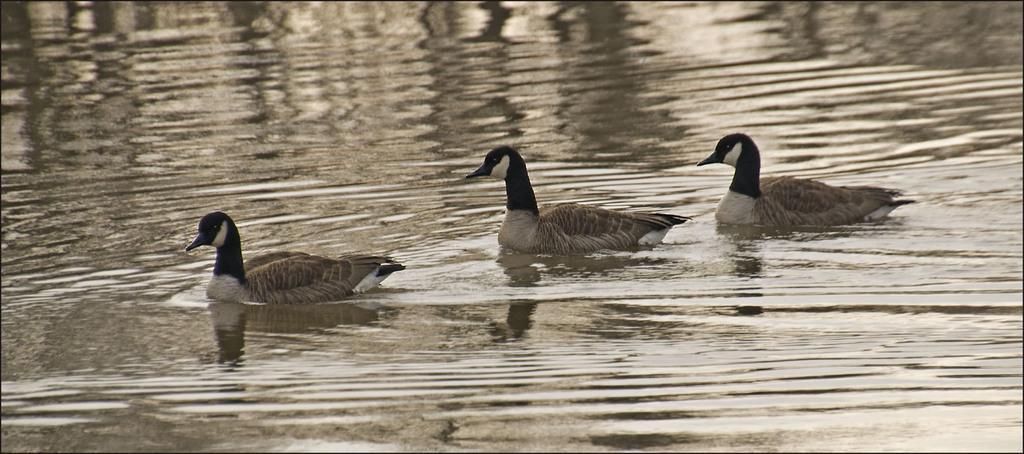In one or two sentences, can you explain what this image depicts? In this picture I can see 3 ducks on the water. 